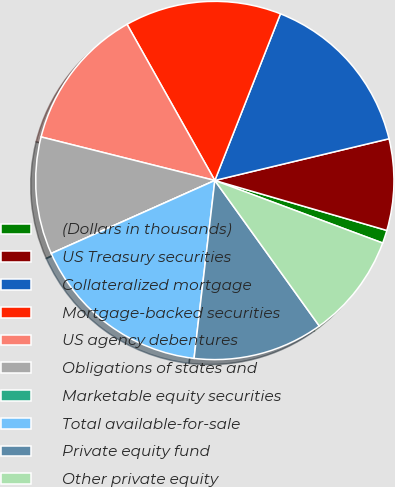<chart> <loc_0><loc_0><loc_500><loc_500><pie_chart><fcel>(Dollars in thousands)<fcel>US Treasury securities<fcel>Collateralized mortgage<fcel>Mortgage-backed securities<fcel>US agency debentures<fcel>Obligations of states and<fcel>Marketable equity securities<fcel>Total available-for-sale<fcel>Private equity fund<fcel>Other private equity<nl><fcel>1.18%<fcel>8.24%<fcel>15.29%<fcel>14.12%<fcel>12.94%<fcel>10.59%<fcel>0.0%<fcel>16.47%<fcel>11.76%<fcel>9.41%<nl></chart> 